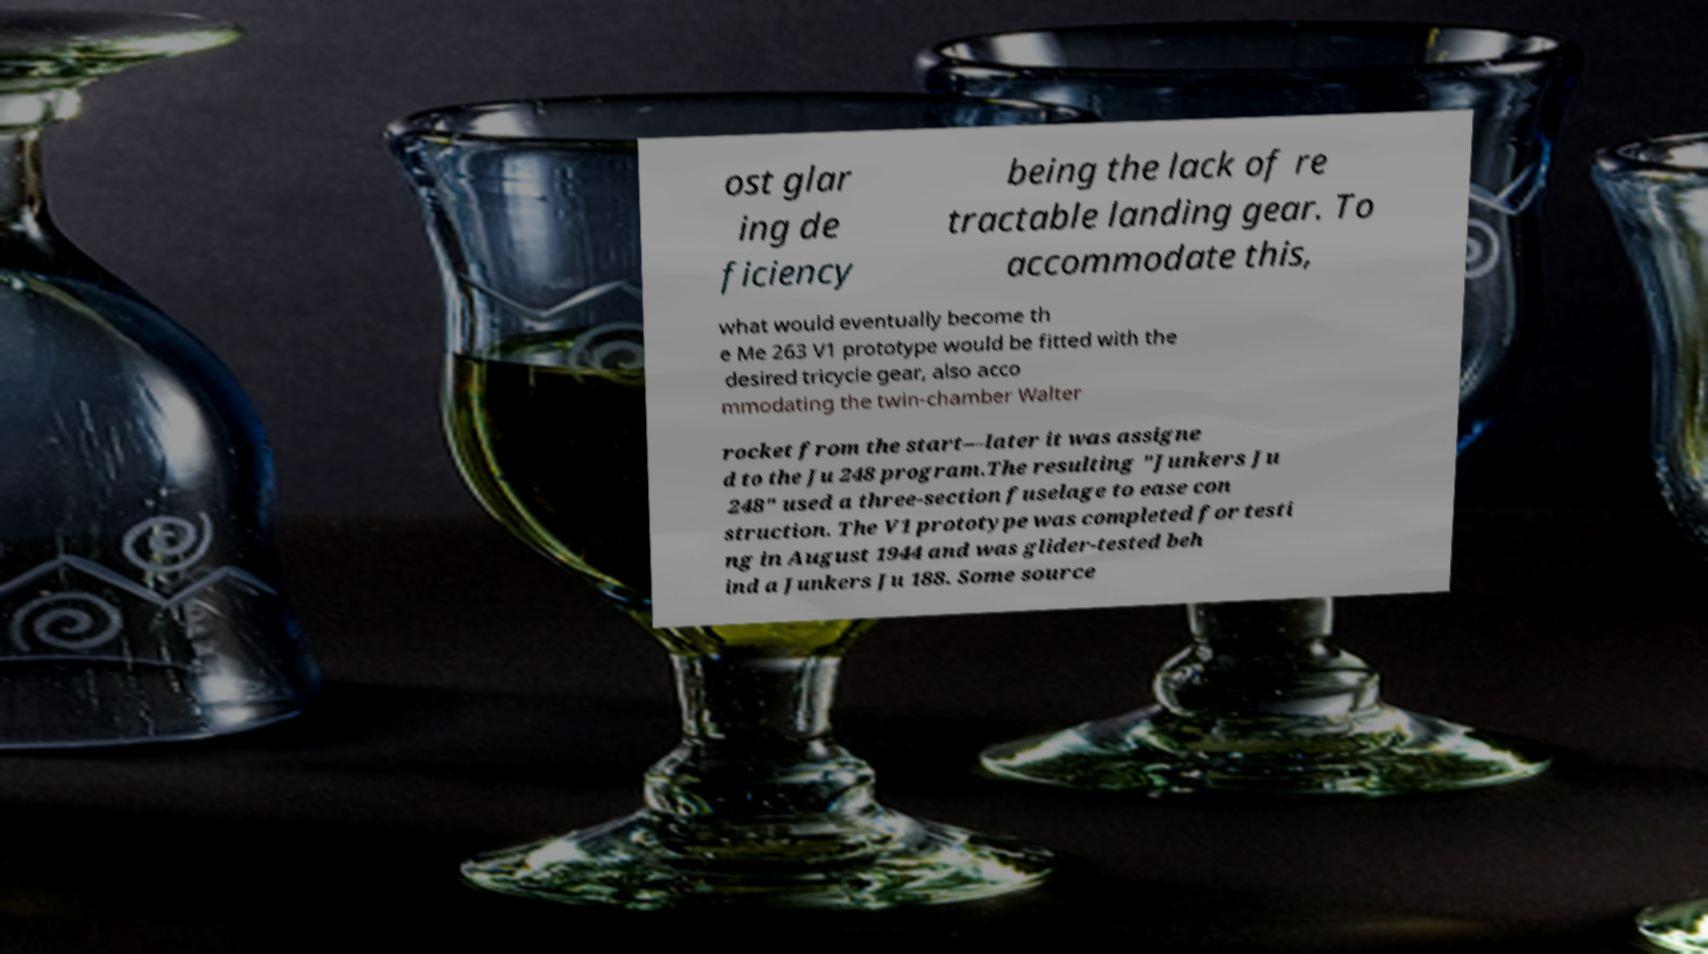For documentation purposes, I need the text within this image transcribed. Could you provide that? ost glar ing de ficiency being the lack of re tractable landing gear. To accommodate this, what would eventually become th e Me 263 V1 prototype would be fitted with the desired tricycle gear, also acco mmodating the twin-chamber Walter rocket from the start—later it was assigne d to the Ju 248 program.The resulting "Junkers Ju 248" used a three-section fuselage to ease con struction. The V1 prototype was completed for testi ng in August 1944 and was glider-tested beh ind a Junkers Ju 188. Some source 